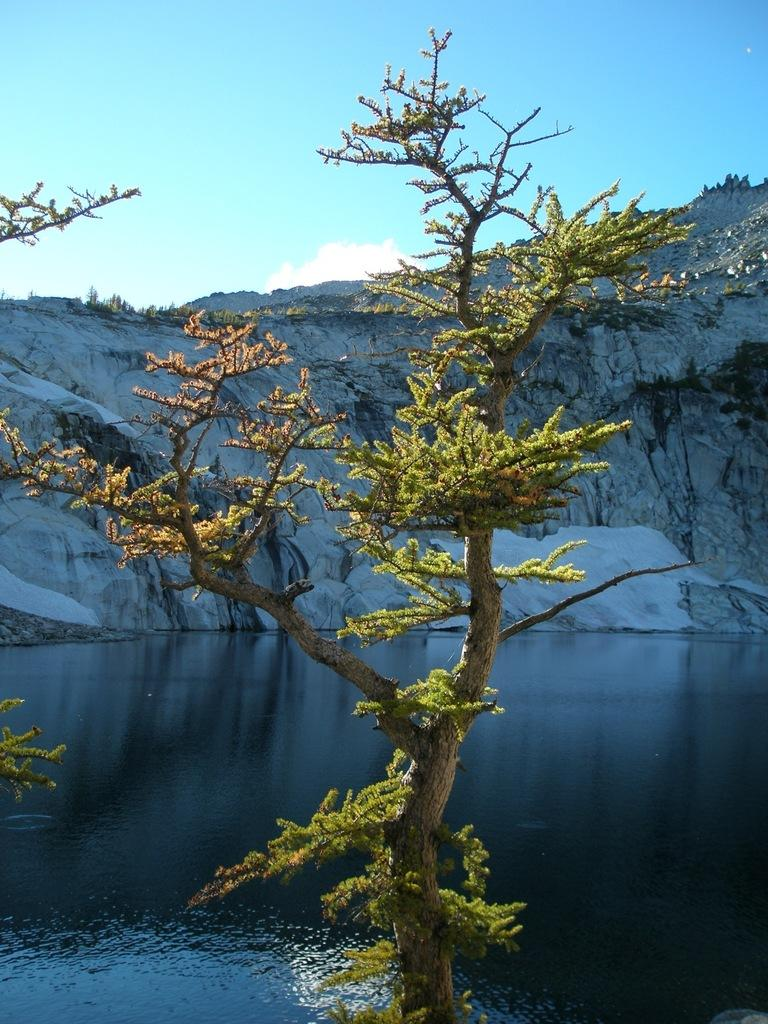What is the main subject in the middle of the picture? There is a tree in the middle of the picture. What is located behind the tree? There is a pond behind the tree. What can be seen in the distance in the background? There is a small hill visible in the background. What is visible above the hill and tree? The sky is visible in the background. Can you tell me how many cacti are growing near the tree in the image? There are no cacti present in the image; it features a tree, a pond, a small hill, and the sky. What thoughts are going through the tree's mind in the image? Trees do not have minds, so it is not possible to determine their thoughts. 